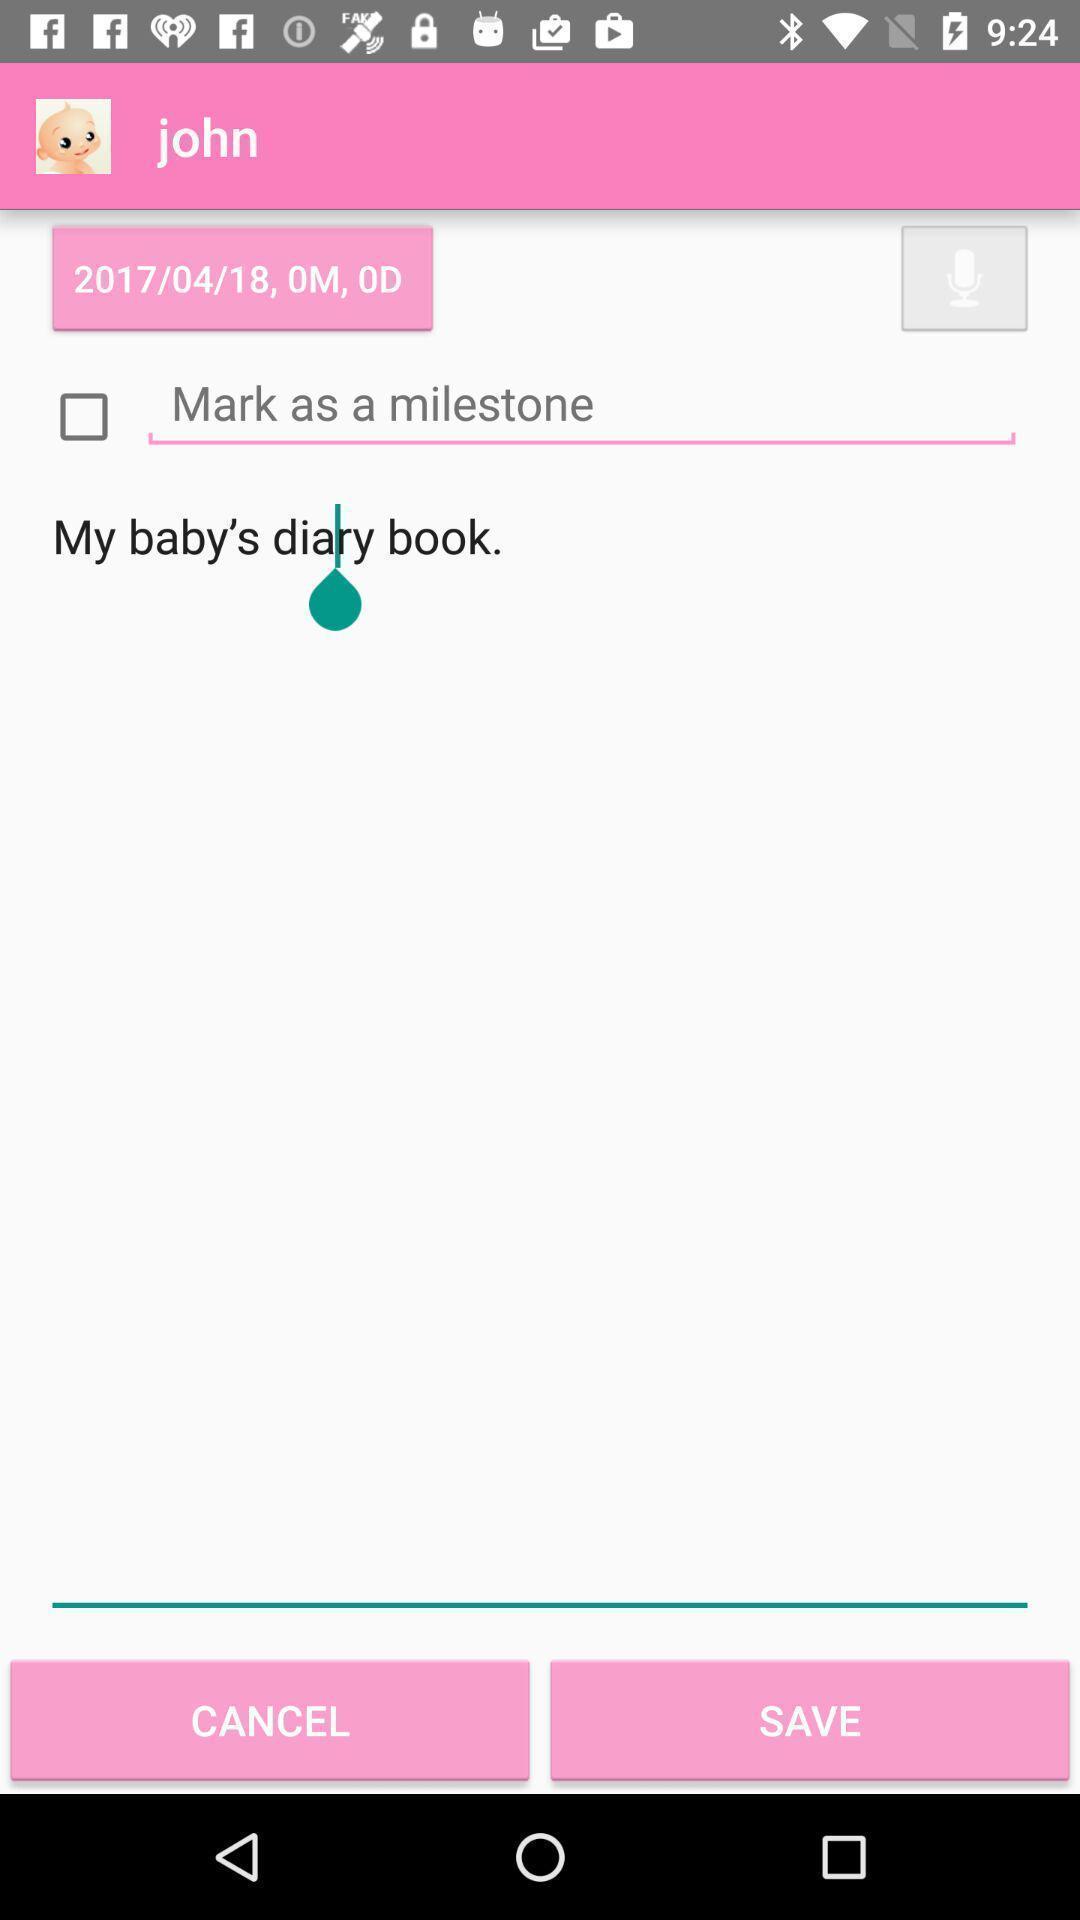Provide a detailed account of this screenshot. Screen showing page with save option. 